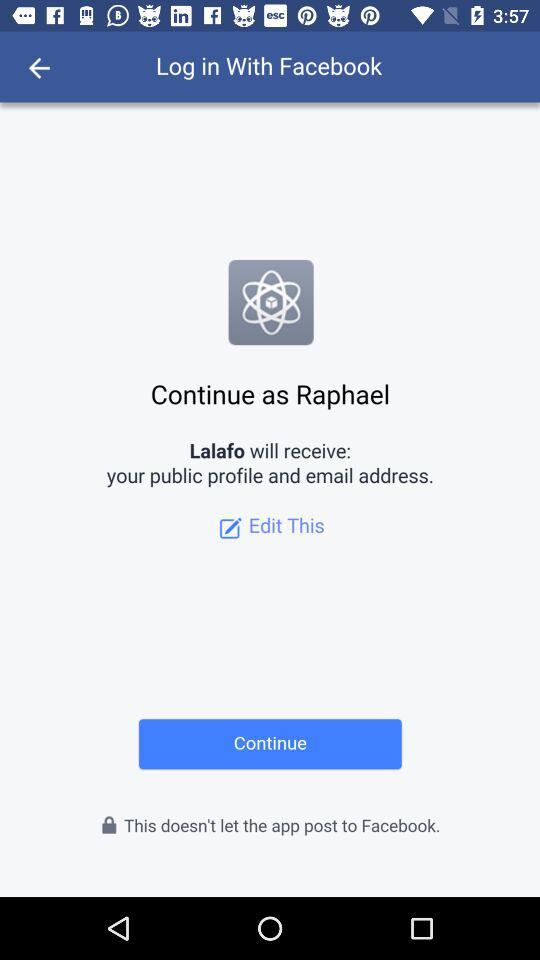What account am I using to continue? You are using "Facebook" to continue. 